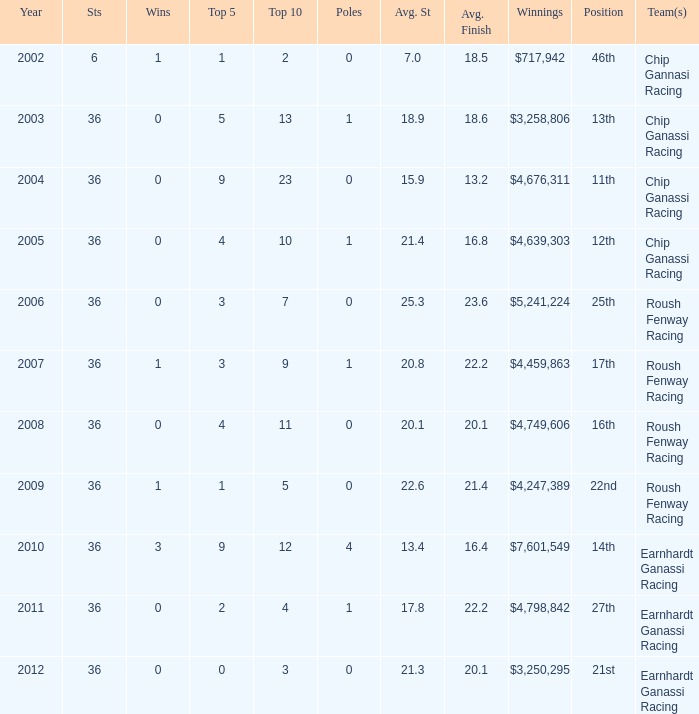Name the starts when position is 16th 36.0. 